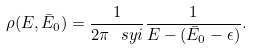Convert formula to latex. <formula><loc_0><loc_0><loc_500><loc_500>\rho ( E , \bar { E } _ { 0 } ) = \frac { 1 } { 2 \pi \ s y { i } } \frac { 1 } { E - ( \bar { E } _ { 0 } - \epsilon ) } .</formula> 